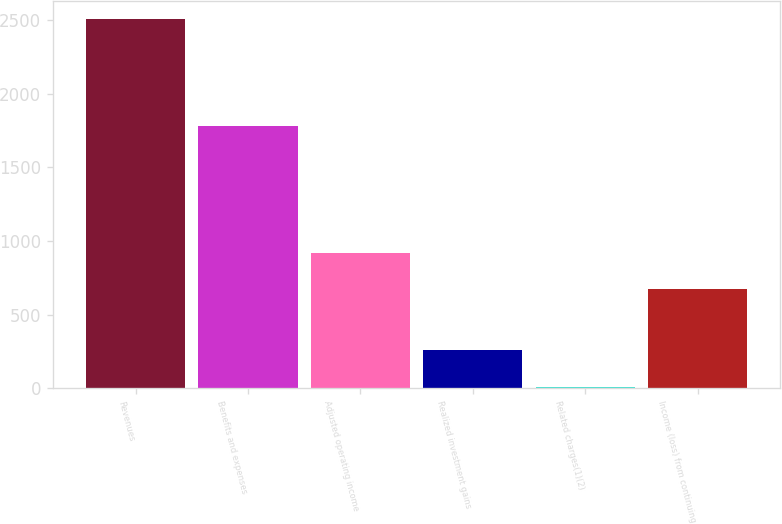Convert chart to OTSL. <chart><loc_0><loc_0><loc_500><loc_500><bar_chart><fcel>Revenues<fcel>Benefits and expenses<fcel>Adjusted operating income<fcel>Realized investment gains<fcel>Related charges(1)(2)<fcel>Income (loss) from continuing<nl><fcel>2503<fcel>1781<fcel>921.1<fcel>261.1<fcel>12<fcel>672<nl></chart> 